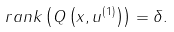Convert formula to latex. <formula><loc_0><loc_0><loc_500><loc_500>r a n k \left ( Q \left ( x , u ^ { \left ( 1 \right ) } \right ) \right ) = \delta .</formula> 